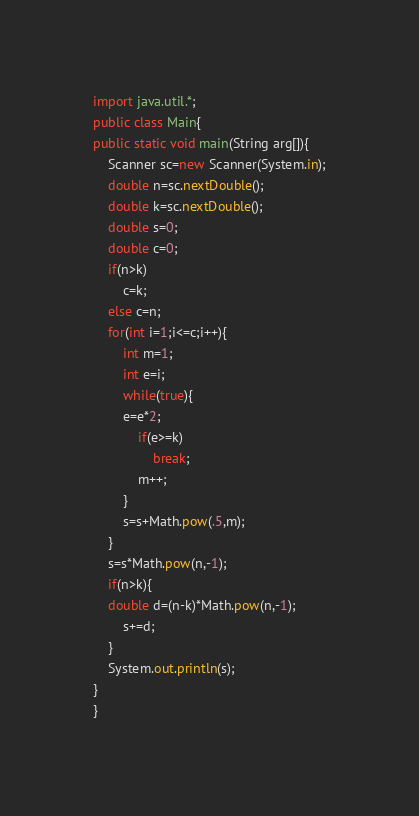Convert code to text. <code><loc_0><loc_0><loc_500><loc_500><_Java_>import java.util.*;
public class Main{
public static void main(String arg[]){
	Scanner sc=new Scanner(System.in);
	double n=sc.nextDouble();
	double k=sc.nextDouble();
	double s=0;
	double c=0;
	if(n>k)
		c=k;
	else c=n;
	for(int i=1;i<=c;i++){
		int m=1;
		int e=i;
		while(true){
		e=e*2;
			if(e>=k)
				break;
			m++;
		}
		s=s+Math.pow(.5,m);
	}
	s=s*Math.pow(n,-1);
	if(n>k){
    double d=(n-k)*Math.pow(n,-1);
		s+=d;
	}
	System.out.println(s);
}
}</code> 